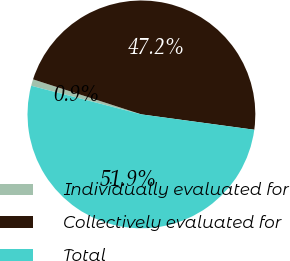Convert chart to OTSL. <chart><loc_0><loc_0><loc_500><loc_500><pie_chart><fcel>Individually evaluated for<fcel>Collectively evaluated for<fcel>Total<nl><fcel>0.93%<fcel>47.18%<fcel>51.9%<nl></chart> 